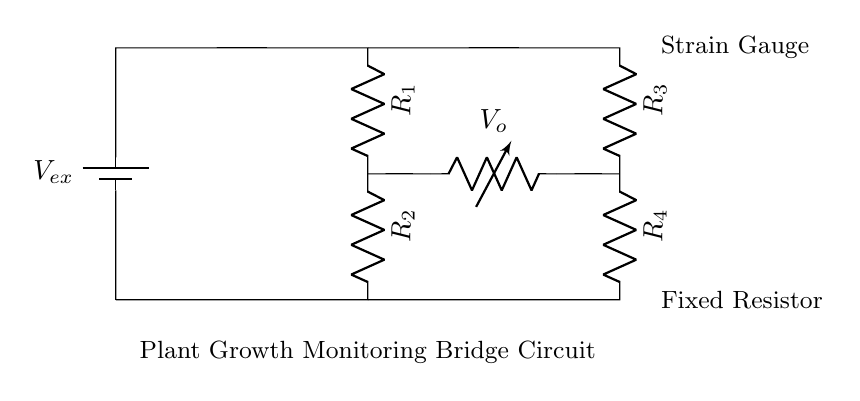What is the purpose of the strain gauge in this circuit? The strain gauge in this circuit is used to measure deformation or strain in the plant, which can indicate growth or movement.
Answer: Measure deformation What components are included in the bridge circuit? The components in the bridge circuit include two resistances from the strain gauge, two fixed resistors, and a voltage source.
Answer: Four resistors and one voltage source How many resistors are part of the bridge circuit? There are four resistors in total; two from the strain gauge side and two fixed resistors.
Answer: Four What is the output voltage denoted as in the circuit? The output voltage is denoted as V_o, indicating the voltage measured across the bridge circuit related to the strain gauge output.
Answer: V_o What type of circuit configuration is used here? The circuit configuration is a Wheatstone bridge, which is typical for measuring small changes in resistance.
Answer: Wheatstone bridge Explain how the output voltage is affected by the strain gauge reading. The output voltage V_o changes in accordance with the resistance changes of the strain gauge; if the strain gauge resistance increases due to strain, V_o will shift according to the balance of the bridge circuit. This behavior results in a differential output that indicates the amount of stretch or compression.
Answer: V_o changes with resistance 